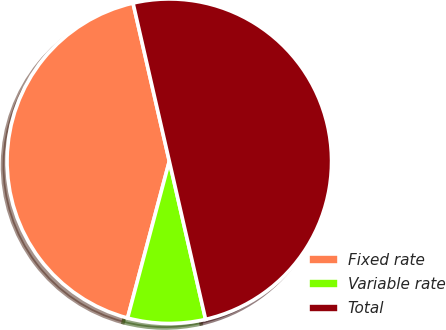Convert chart to OTSL. <chart><loc_0><loc_0><loc_500><loc_500><pie_chart><fcel>Fixed rate<fcel>Variable rate<fcel>Total<nl><fcel>42.27%<fcel>7.73%<fcel>50.0%<nl></chart> 